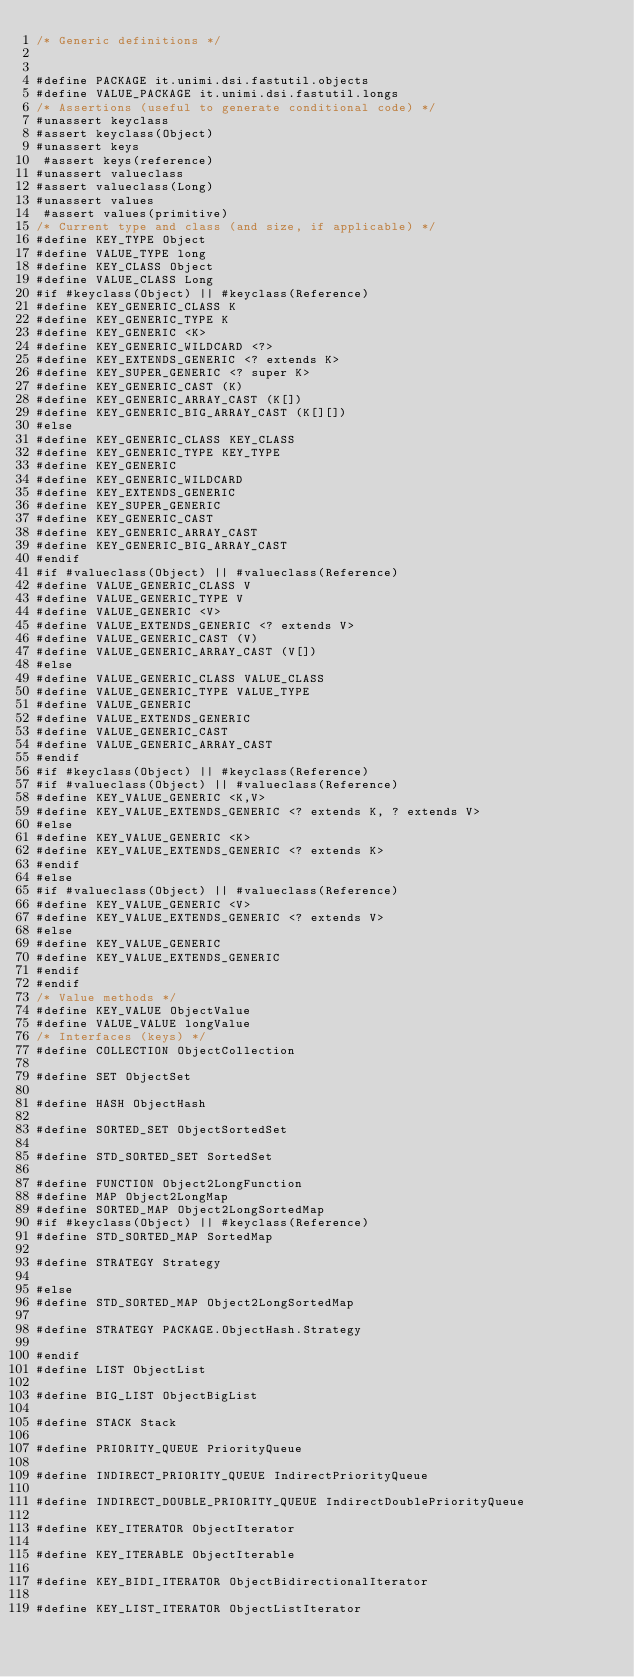<code> <loc_0><loc_0><loc_500><loc_500><_C_>/* Generic definitions */


#define PACKAGE it.unimi.dsi.fastutil.objects
#define VALUE_PACKAGE it.unimi.dsi.fastutil.longs
/* Assertions (useful to generate conditional code) */
#unassert keyclass
#assert keyclass(Object)
#unassert keys
 #assert keys(reference)
#unassert valueclass
#assert valueclass(Long)
#unassert values
 #assert values(primitive)
/* Current type and class (and size, if applicable) */
#define KEY_TYPE Object
#define VALUE_TYPE long
#define KEY_CLASS Object
#define VALUE_CLASS Long
#if #keyclass(Object) || #keyclass(Reference)
#define KEY_GENERIC_CLASS K
#define KEY_GENERIC_TYPE K
#define KEY_GENERIC <K>
#define KEY_GENERIC_WILDCARD <?>
#define KEY_EXTENDS_GENERIC <? extends K>
#define KEY_SUPER_GENERIC <? super K>
#define KEY_GENERIC_CAST (K)
#define KEY_GENERIC_ARRAY_CAST (K[])
#define KEY_GENERIC_BIG_ARRAY_CAST (K[][])
#else
#define KEY_GENERIC_CLASS KEY_CLASS
#define KEY_GENERIC_TYPE KEY_TYPE
#define KEY_GENERIC
#define KEY_GENERIC_WILDCARD
#define KEY_EXTENDS_GENERIC
#define KEY_SUPER_GENERIC
#define KEY_GENERIC_CAST
#define KEY_GENERIC_ARRAY_CAST
#define KEY_GENERIC_BIG_ARRAY_CAST
#endif
#if #valueclass(Object) || #valueclass(Reference)
#define VALUE_GENERIC_CLASS V
#define VALUE_GENERIC_TYPE V
#define VALUE_GENERIC <V>
#define VALUE_EXTENDS_GENERIC <? extends V>
#define VALUE_GENERIC_CAST (V)
#define VALUE_GENERIC_ARRAY_CAST (V[])
#else
#define VALUE_GENERIC_CLASS VALUE_CLASS
#define VALUE_GENERIC_TYPE VALUE_TYPE
#define VALUE_GENERIC
#define VALUE_EXTENDS_GENERIC
#define VALUE_GENERIC_CAST
#define VALUE_GENERIC_ARRAY_CAST
#endif
#if #keyclass(Object) || #keyclass(Reference)
#if #valueclass(Object) || #valueclass(Reference)
#define KEY_VALUE_GENERIC <K,V>
#define KEY_VALUE_EXTENDS_GENERIC <? extends K, ? extends V>
#else
#define KEY_VALUE_GENERIC <K>
#define KEY_VALUE_EXTENDS_GENERIC <? extends K>
#endif
#else
#if #valueclass(Object) || #valueclass(Reference)
#define KEY_VALUE_GENERIC <V>
#define KEY_VALUE_EXTENDS_GENERIC <? extends V>
#else
#define KEY_VALUE_GENERIC
#define KEY_VALUE_EXTENDS_GENERIC
#endif
#endif
/* Value methods */
#define KEY_VALUE ObjectValue
#define VALUE_VALUE longValue
/* Interfaces (keys) */
#define COLLECTION ObjectCollection

#define SET ObjectSet

#define HASH ObjectHash

#define SORTED_SET ObjectSortedSet

#define STD_SORTED_SET SortedSet

#define FUNCTION Object2LongFunction
#define MAP Object2LongMap
#define SORTED_MAP Object2LongSortedMap
#if #keyclass(Object) || #keyclass(Reference)
#define STD_SORTED_MAP SortedMap

#define STRATEGY Strategy

#else
#define STD_SORTED_MAP Object2LongSortedMap

#define STRATEGY PACKAGE.ObjectHash.Strategy

#endif
#define LIST ObjectList

#define BIG_LIST ObjectBigList

#define STACK Stack

#define PRIORITY_QUEUE PriorityQueue

#define INDIRECT_PRIORITY_QUEUE IndirectPriorityQueue

#define INDIRECT_DOUBLE_PRIORITY_QUEUE IndirectDoublePriorityQueue

#define KEY_ITERATOR ObjectIterator

#define KEY_ITERABLE ObjectIterable

#define KEY_BIDI_ITERATOR ObjectBidirectionalIterator

#define KEY_LIST_ITERATOR ObjectListIterator
</code> 